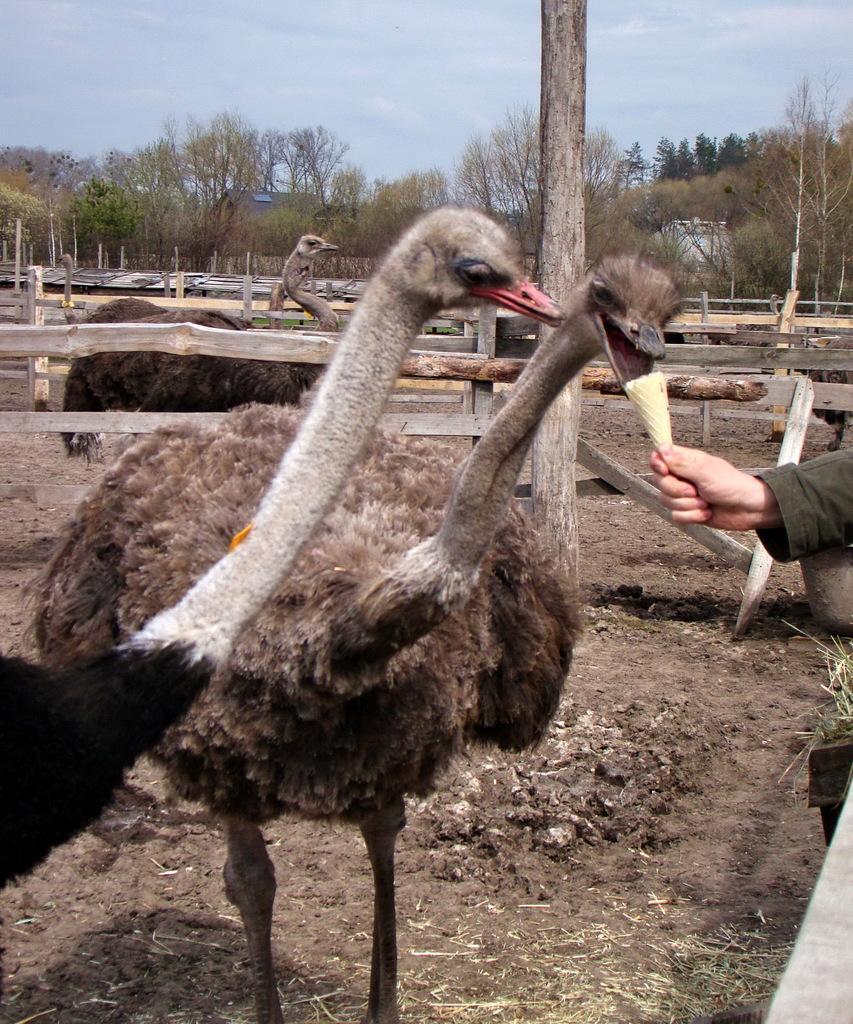In one or two sentences, can you explain what this image depicts? In the image we can see there are many ostrich and trees. Here we can see wooden fence, pole and the cloudy sky. We can even see a human hand holding ice cream cone. 